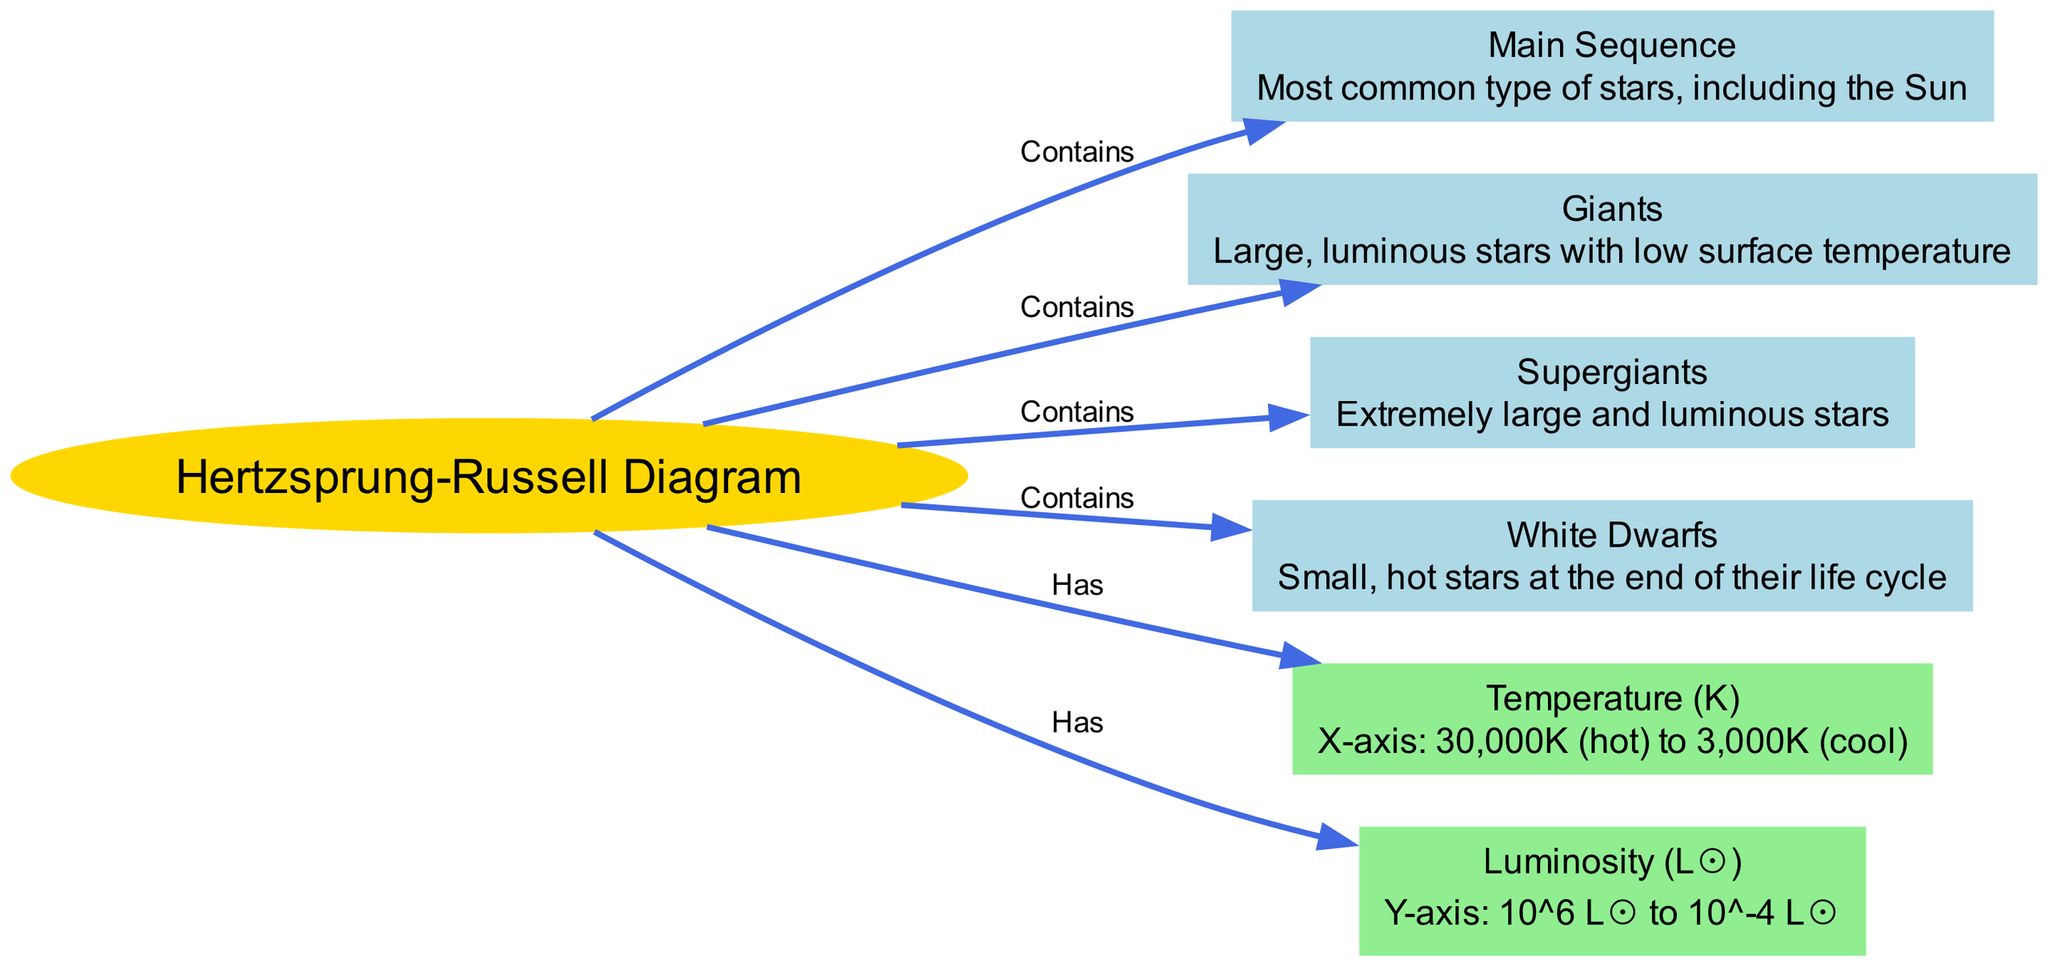What is the main type of stars shown in the diagram? The diagram contains a specific node labeled "Main Sequence," which is described as the most common type of stars. It is directly connected to the Hertzsprung-Russell diagram.
Answer: Main Sequence How many different star classifications are included in the diagram? The diagram includes four classifications of stars: Main Sequence, Giants, Supergiants, and White Dwarfs, which can be counted in the nodes.
Answer: Four What does the x-axis represent in the diagram? The x-axis is labeled "Temperature (K)," and its description indicates it ranges from 30,000K for hot stars to 3,000K for cool stars, which is found in the temperature axis node.
Answer: Temperature (K) Which type of stars are characterized as extremely large and luminous? In the diagram, the node for "Supergiants" specifically describes these qualities, thus making it the type denoting extremely large and luminous stars.
Answer: Supergiants What are the two axes contained in the Hertzsprung-Russell Diagram? The diagram has two axes as indicated by the edges: "Temperature (K)" for the x-axis and "Luminosity (L☉)" for the y-axis, which can be directly referenced from the edges connected to the hr_diagram.
Answer: Temperature (K), Luminosity (L☉) Which classification of stars is noted as small, hot stars at the end of their life cycle? The node labeled "White Dwarfs" describes small, hot stars at the end of their life cycle, drawing from the details in the classification nodes.
Answer: White Dwarfs What is the range of temperature on the x-axis? The description of the temperature axis specifically states it ranges from 30,000K (hot) to 3,000K (cool), which is directly mentioned in the diagram.
Answer: 30,000K to 3,000K Which two star classifications would you find above the Main Sequence? The diagram contains nodes for "Giants" and "Supergiants," which are typically located above the Main Sequence based on their position related to the luminosity axis in star classification.
Answer: Giants, Supergiants 